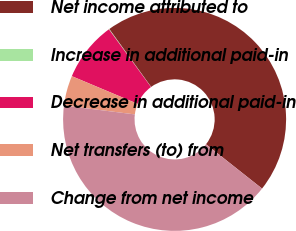Convert chart. <chart><loc_0><loc_0><loc_500><loc_500><pie_chart><fcel>Net income attributed to<fcel>Increase in additional paid-in<fcel>Decrease in additional paid-in<fcel>Net transfers (to) from<fcel>Change from net income<nl><fcel>45.62%<fcel>0.07%<fcel>8.63%<fcel>4.35%<fcel>41.34%<nl></chart> 